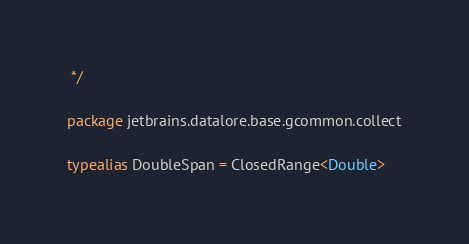<code> <loc_0><loc_0><loc_500><loc_500><_Kotlin_> */

package jetbrains.datalore.base.gcommon.collect

typealias DoubleSpan = ClosedRange<Double></code> 